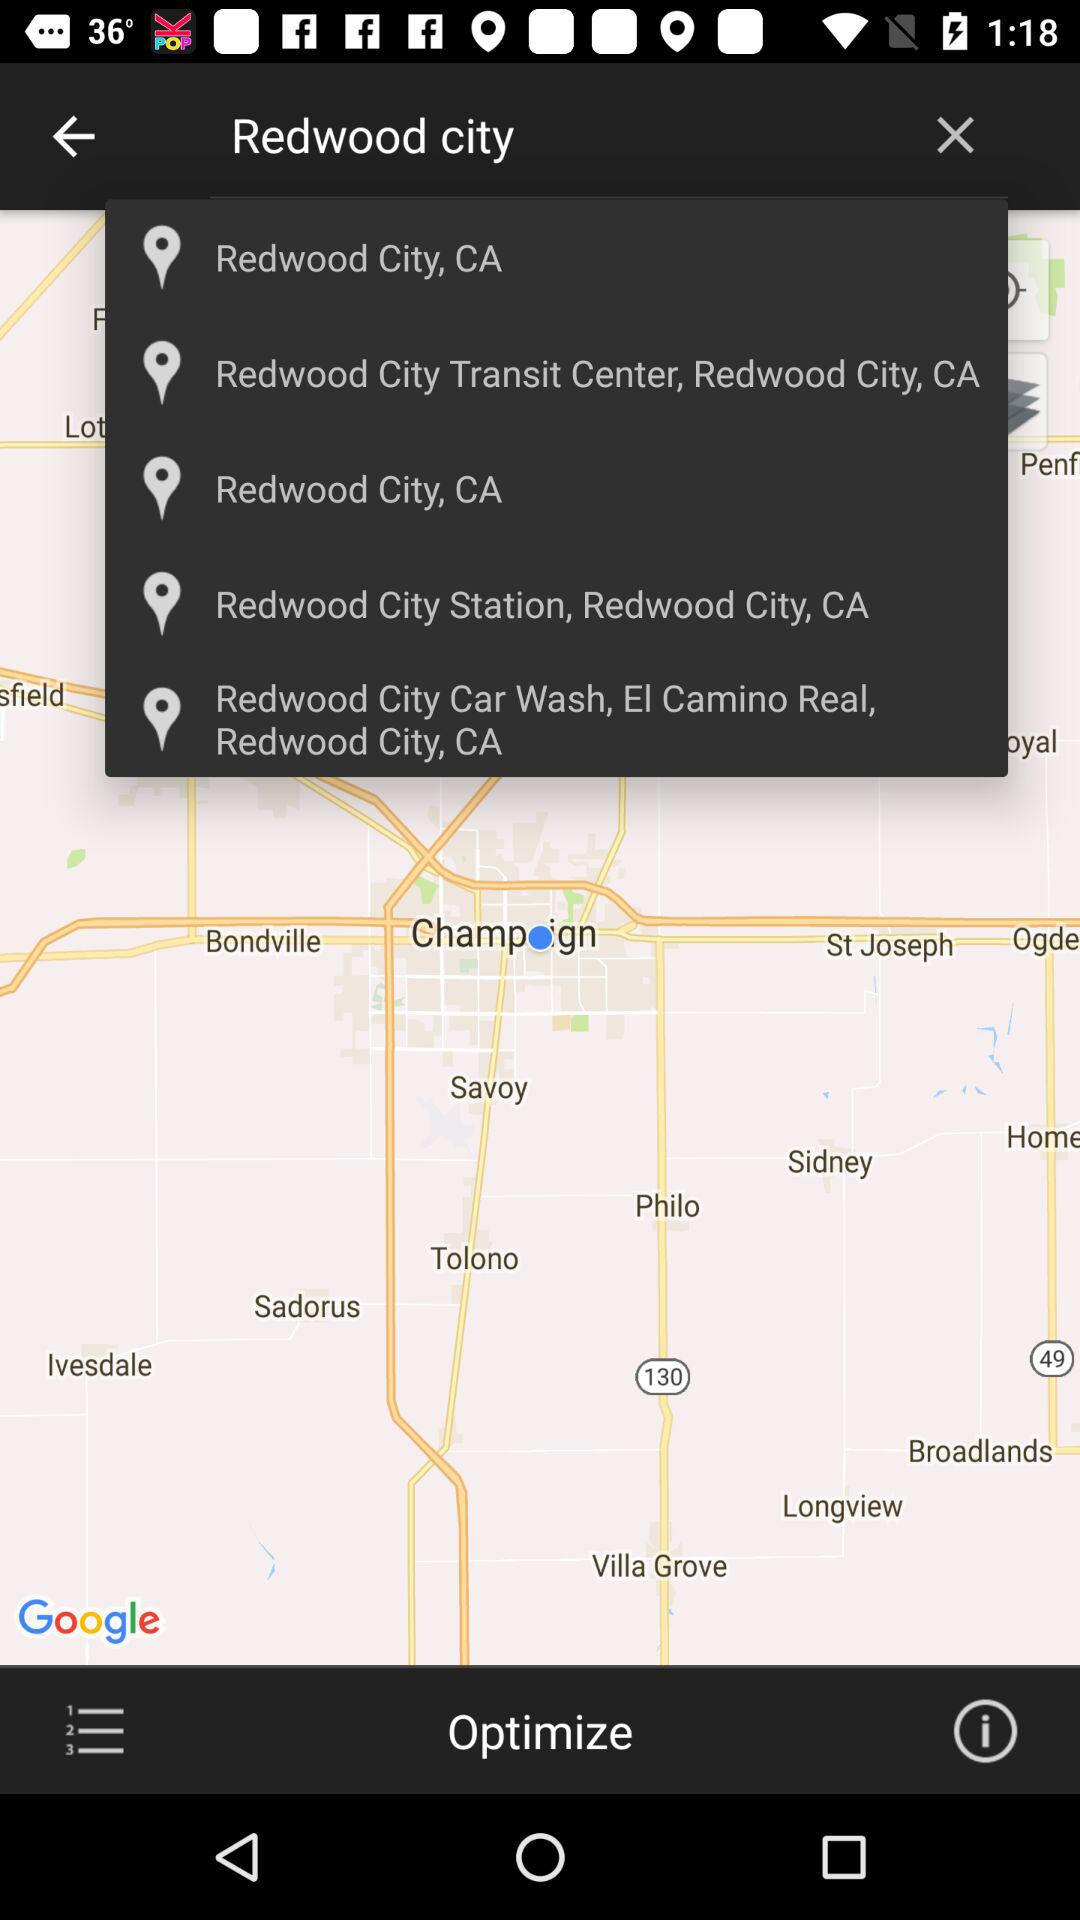What location is searched? The searched location is "Redwood city". 